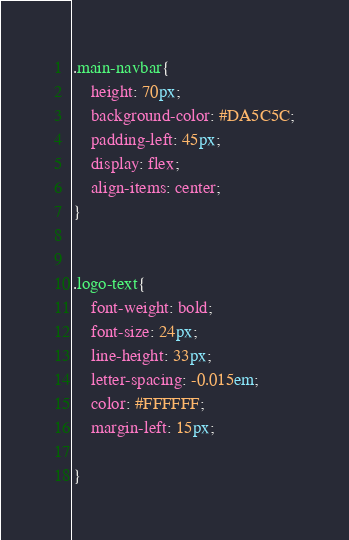Convert code to text. <code><loc_0><loc_0><loc_500><loc_500><_CSS_>.main-navbar{
    height: 70px;
    background-color: #DA5C5C;
    padding-left: 45px;
    display: flex;
    align-items: center;
}


.logo-text{
    font-weight: bold;
    font-size: 24px;
    line-height: 33px;
    letter-spacing: -0.015em;
    color: #FFFFFF;
    margin-left: 15px;

}</code> 